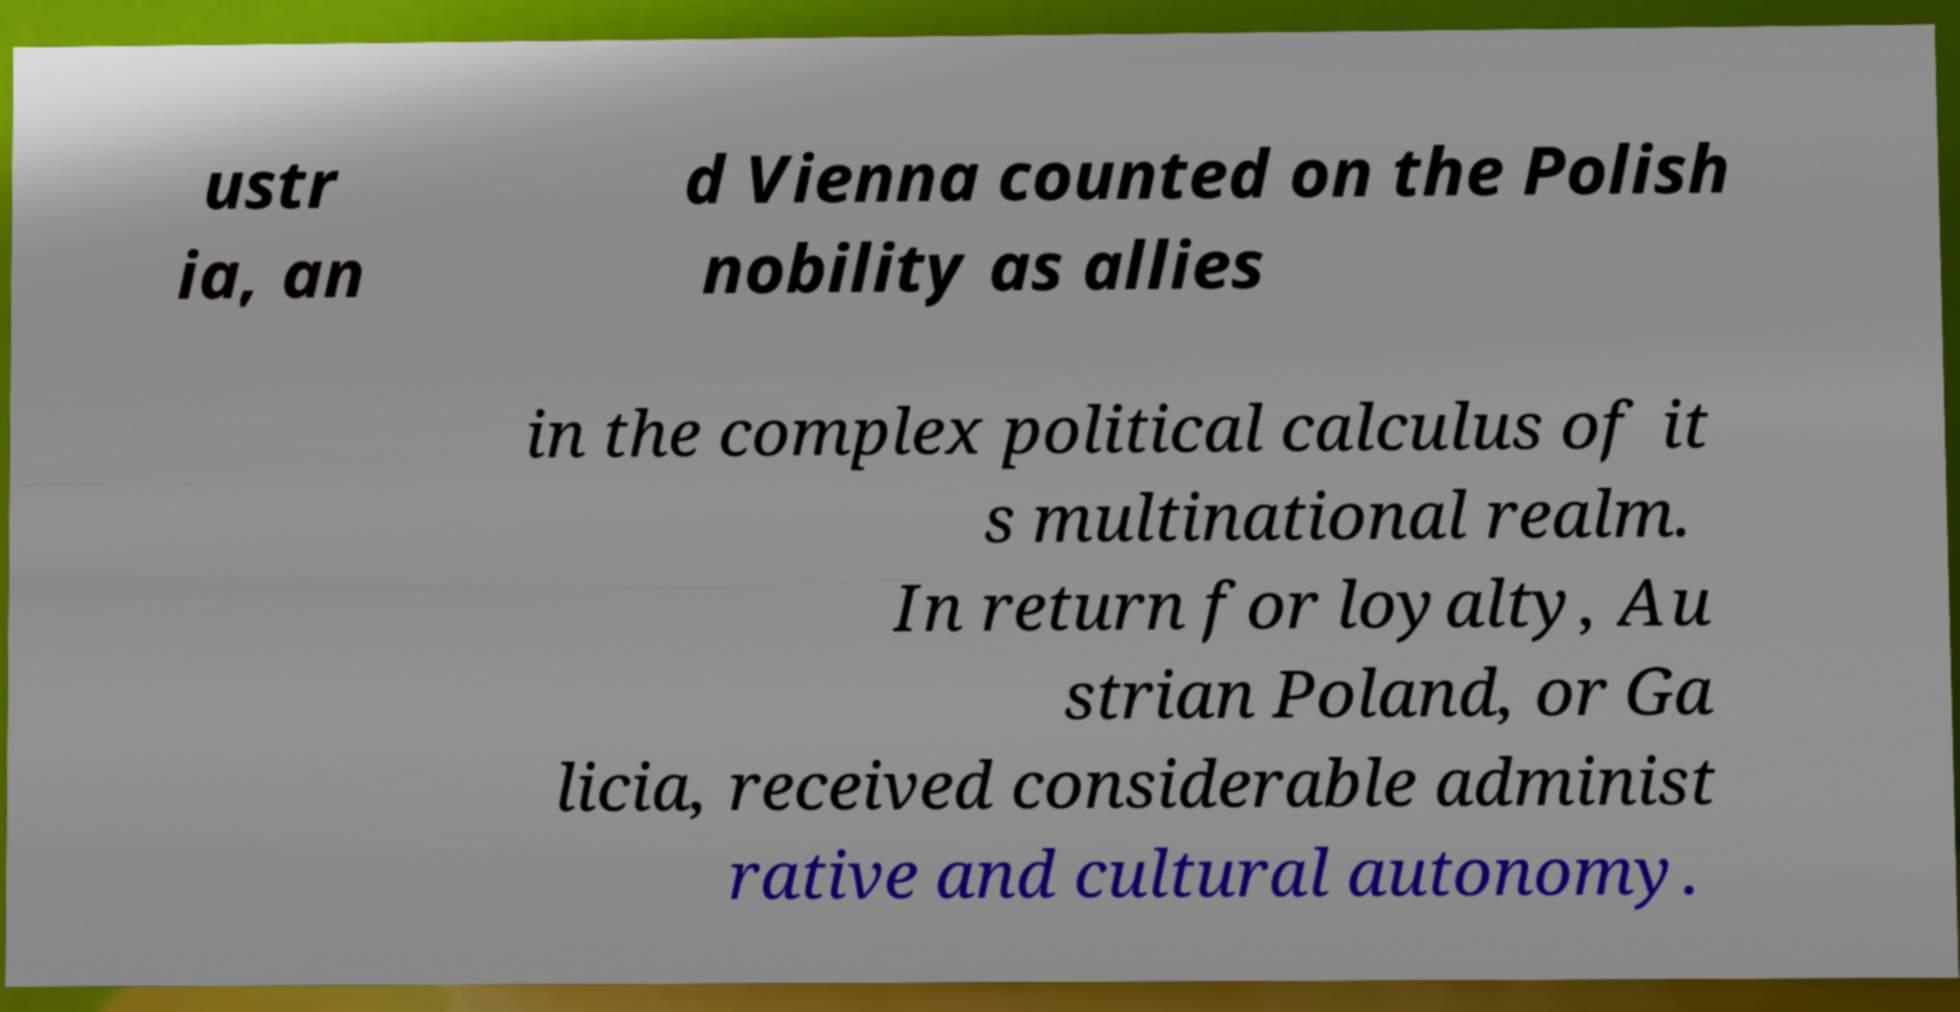There's text embedded in this image that I need extracted. Can you transcribe it verbatim? ustr ia, an d Vienna counted on the Polish nobility as allies in the complex political calculus of it s multinational realm. In return for loyalty, Au strian Poland, or Ga licia, received considerable administ rative and cultural autonomy. 